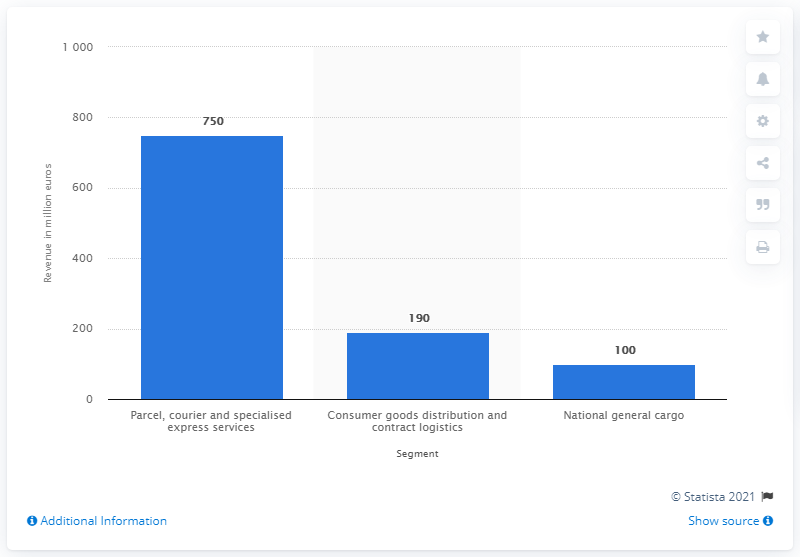Point out several critical features in this image. In 2009, Hermes' national general cargo revenue amounted to approximately $100 million. 